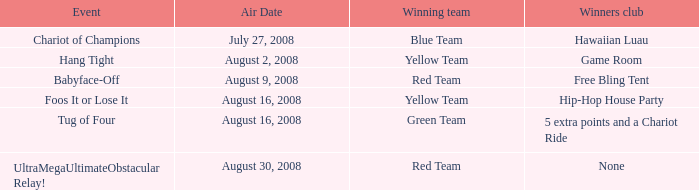Which conquerors club has an event of grip firmly? Game Room. Would you mind parsing the complete table? {'header': ['Event', 'Air Date', 'Winning team', 'Winners club'], 'rows': [['Chariot of Champions', 'July 27, 2008', 'Blue Team', 'Hawaiian Luau'], ['Hang Tight', 'August 2, 2008', 'Yellow Team', 'Game Room'], ['Babyface-Off', 'August 9, 2008', 'Red Team', 'Free Bling Tent'], ['Foos It or Lose It', 'August 16, 2008', 'Yellow Team', 'Hip-Hop House Party'], ['Tug of Four', 'August 16, 2008', 'Green Team', '5 extra points and a Chariot Ride'], ['UltraMegaUltimateObstacular Relay!', 'August 30, 2008', 'Red Team', 'None']]} 